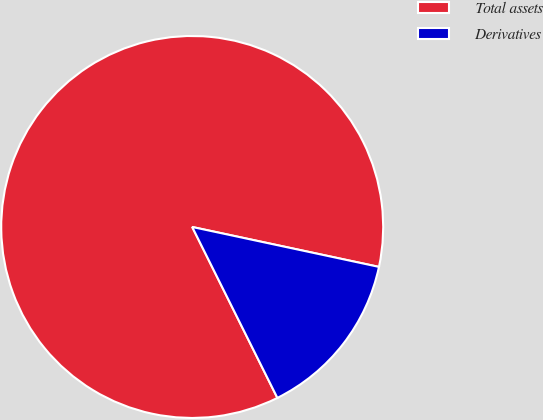Convert chart to OTSL. <chart><loc_0><loc_0><loc_500><loc_500><pie_chart><fcel>Total assets<fcel>Derivatives<nl><fcel>85.71%<fcel>14.29%<nl></chart> 